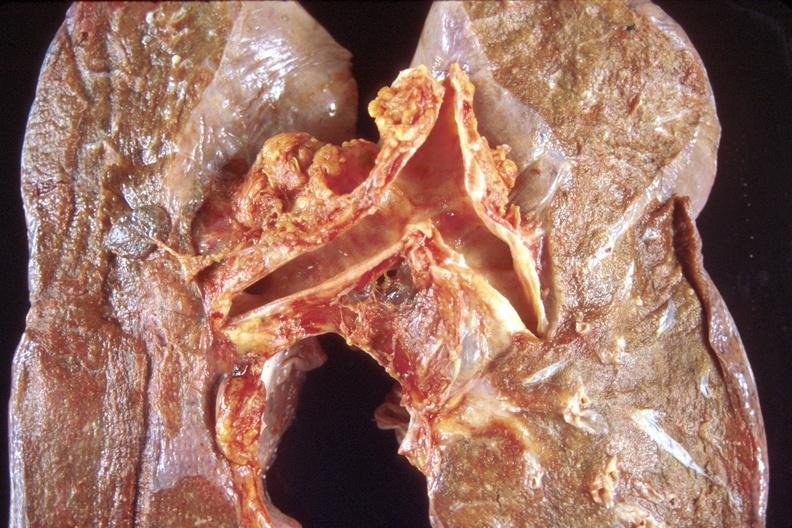what does this image show?
Answer the question using a single word or phrase. Normal lung 